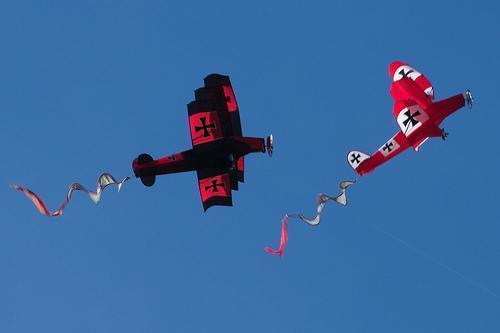How many kites are in this picture?
Give a very brief answer. 2. 